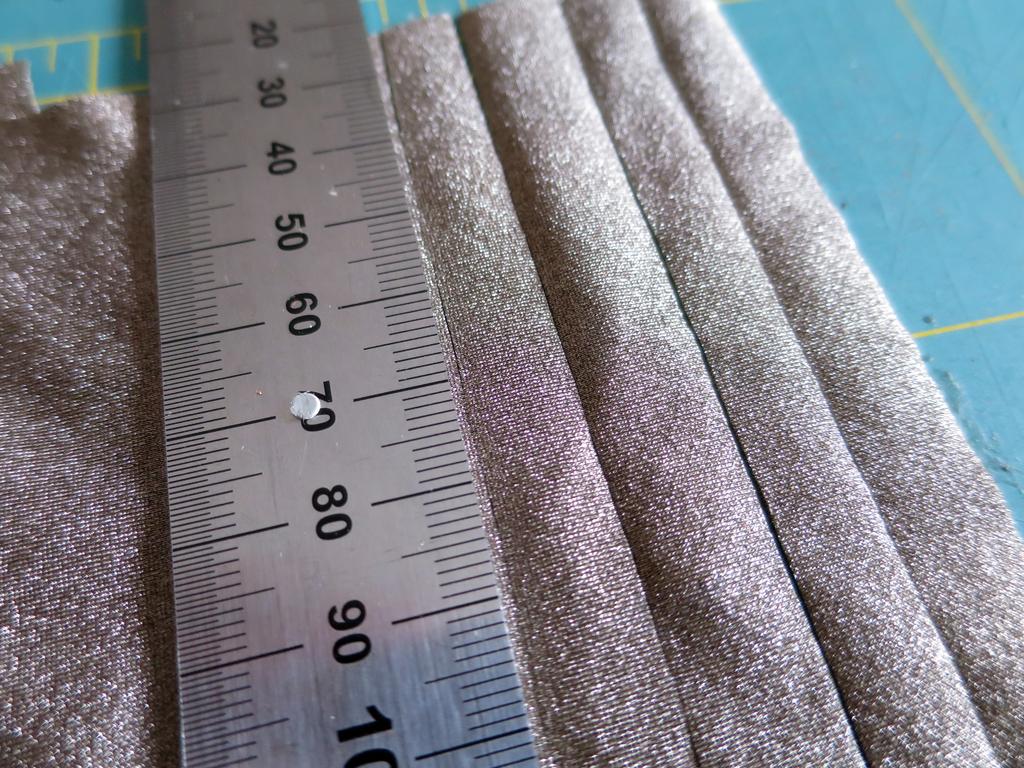How far does this numbering go?
Give a very brief answer. 100. What's the number to the very top?
Your answer should be compact. 20. 